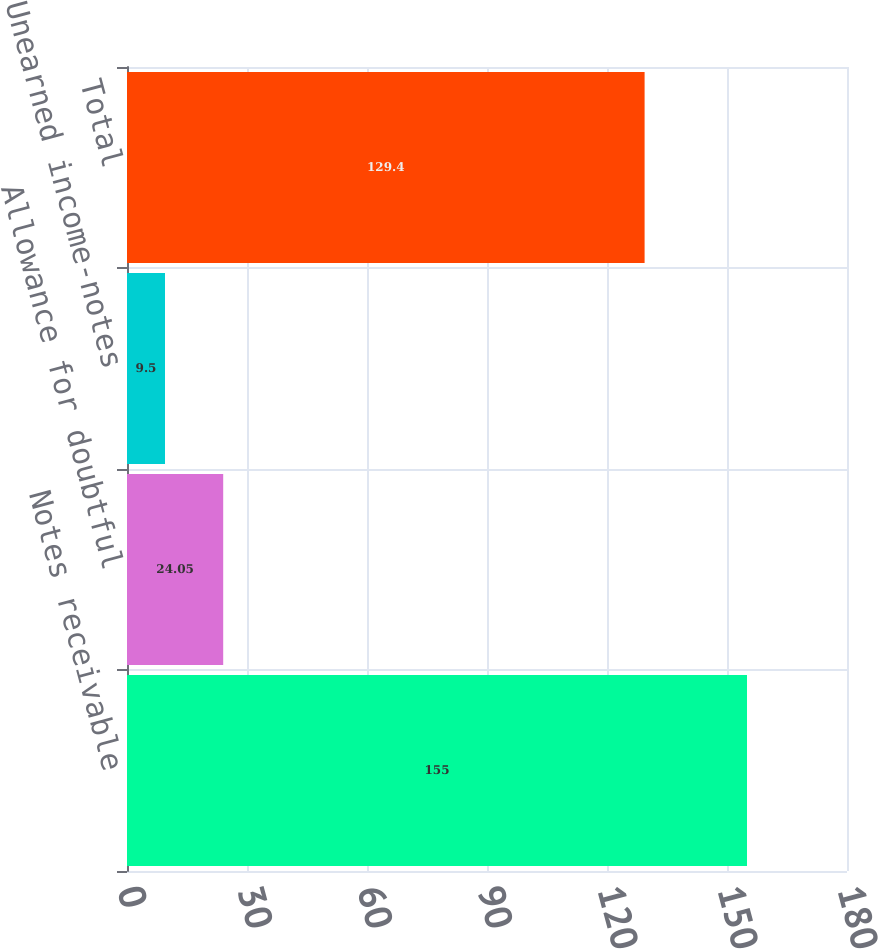Convert chart to OTSL. <chart><loc_0><loc_0><loc_500><loc_500><bar_chart><fcel>Notes receivable<fcel>Allowance for doubtful<fcel>Unearned income-notes<fcel>Total<nl><fcel>155<fcel>24.05<fcel>9.5<fcel>129.4<nl></chart> 